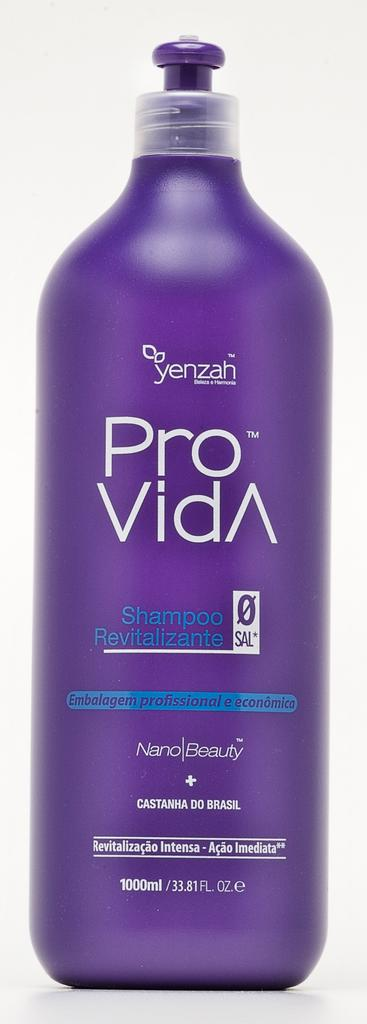<image>
Provide a brief description of the given image. a purple bottle with the word yenzah on it and blue shampoo lettering 